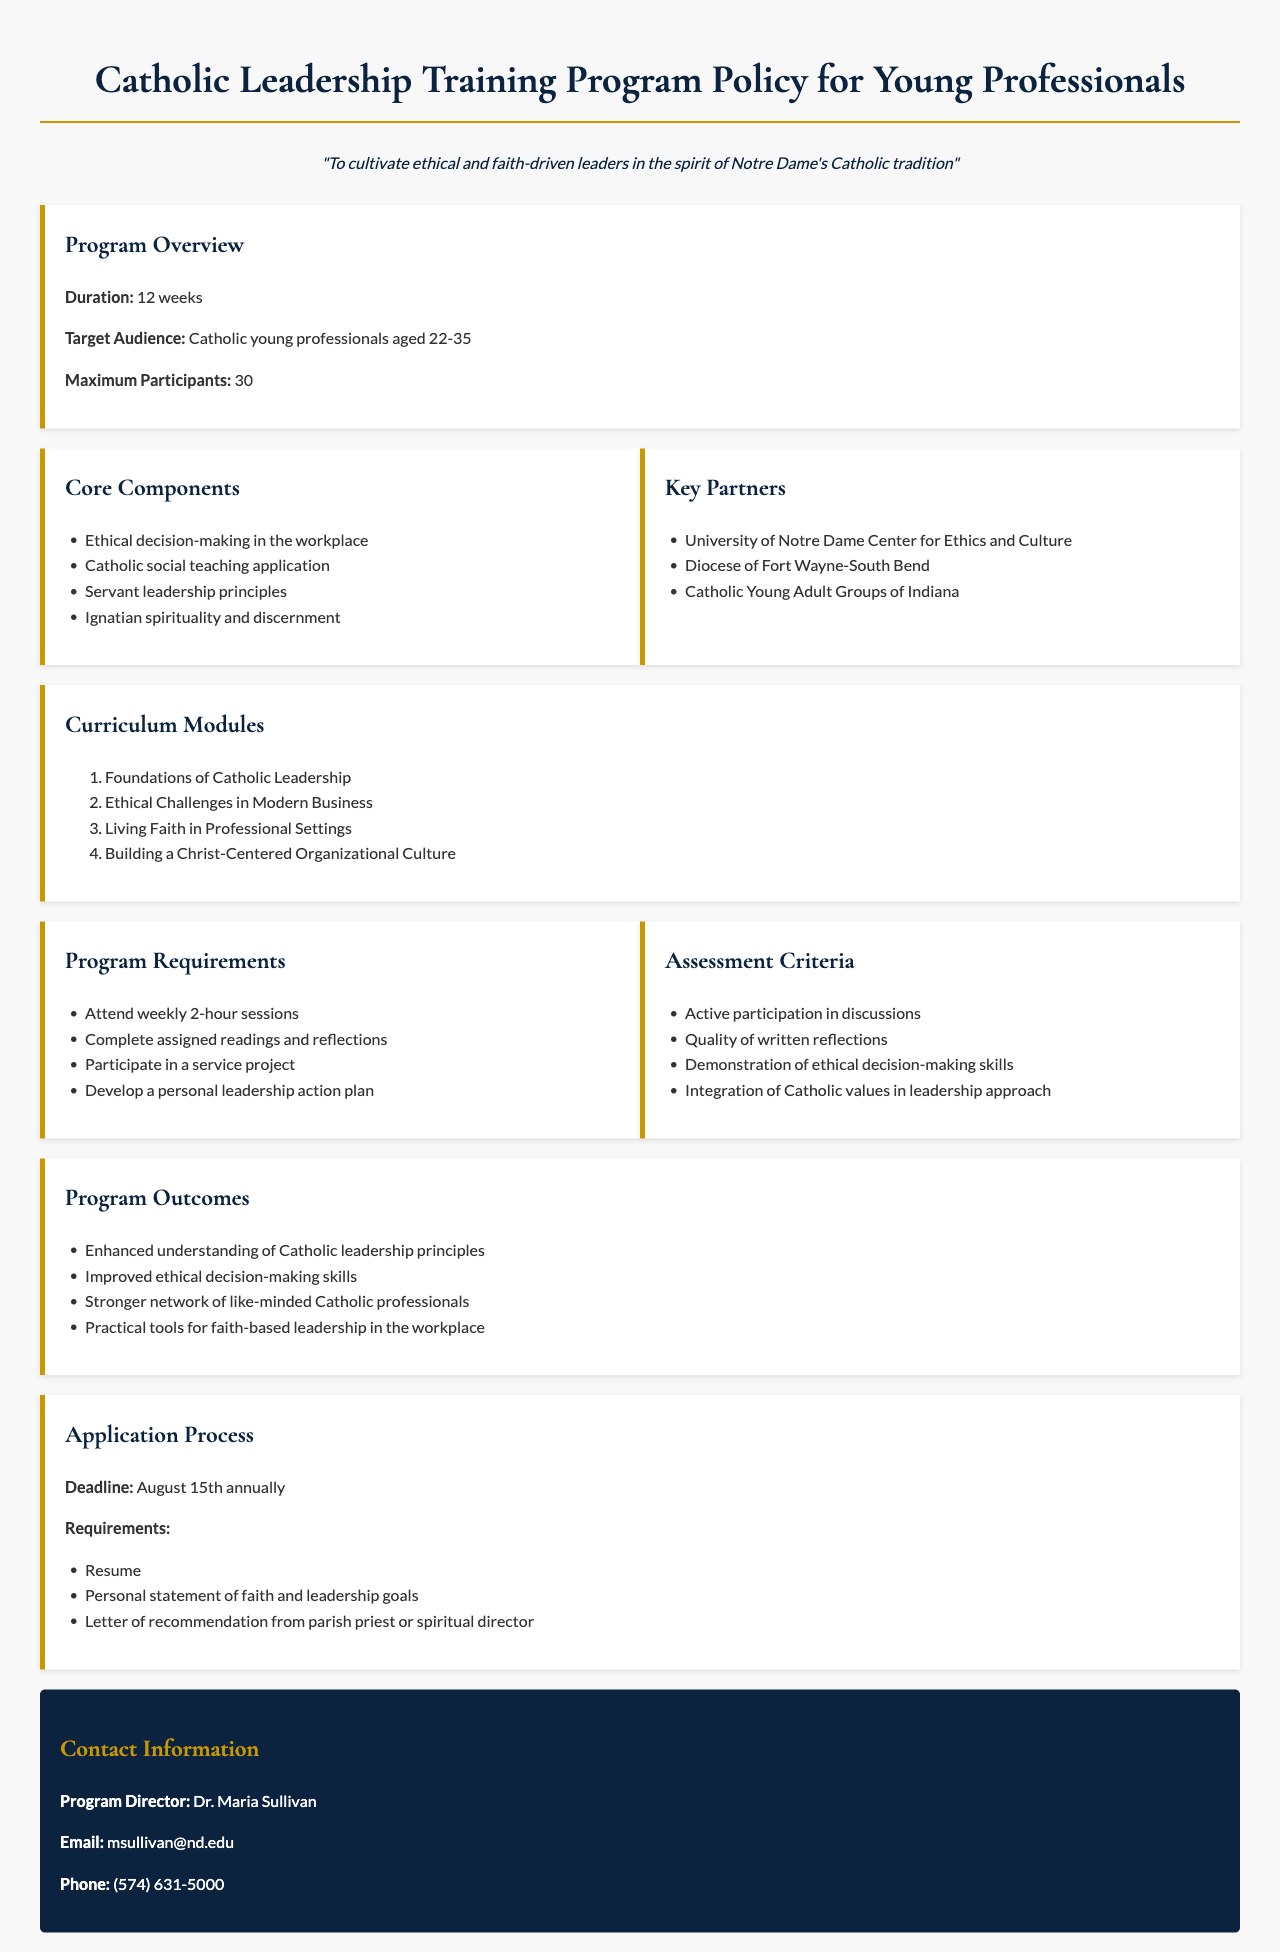What is the duration of the program? The duration of the program is specified in the "Program Overview" section as 12 weeks.
Answer: 12 weeks Who is the target audience for this program? The target audience is mentioned in the "Program Overview" as Catholic young professionals aged 22-35.
Answer: Catholic young professionals aged 22-35 How many participants can the program accommodate? The document specifies the maximum number of participants in the "Program Overview" section as 30.
Answer: 30 What is one of the core components of the program? The "Core Components" section lists several items, such as ethical decision-making in the workplace.
Answer: Ethical decision-making in the workplace What is the application deadline for the program? The "Application Process" section states that the deadline is August 15th annually.
Answer: August 15th annually Name one key partner of the program. The document lists collaborations in the "Key Partners" section, one of which is the University of Notre Dame Center for Ethics and Culture.
Answer: University of Notre Dame Center for Ethics and Culture What type of project must participants complete? The "Program Requirements" section mentions a service project as a requirement for participants.
Answer: Service project Which curriculum module addresses modern business challenges? The "Curriculum Modules" section includes a module titled "Ethical Challenges in Modern Business."
Answer: Ethical Challenges in Modern Business What is required in the personal statement during the application? The "Application Process" mentions that the personal statement should include faith and leadership goals.
Answer: Faith and leadership goals 